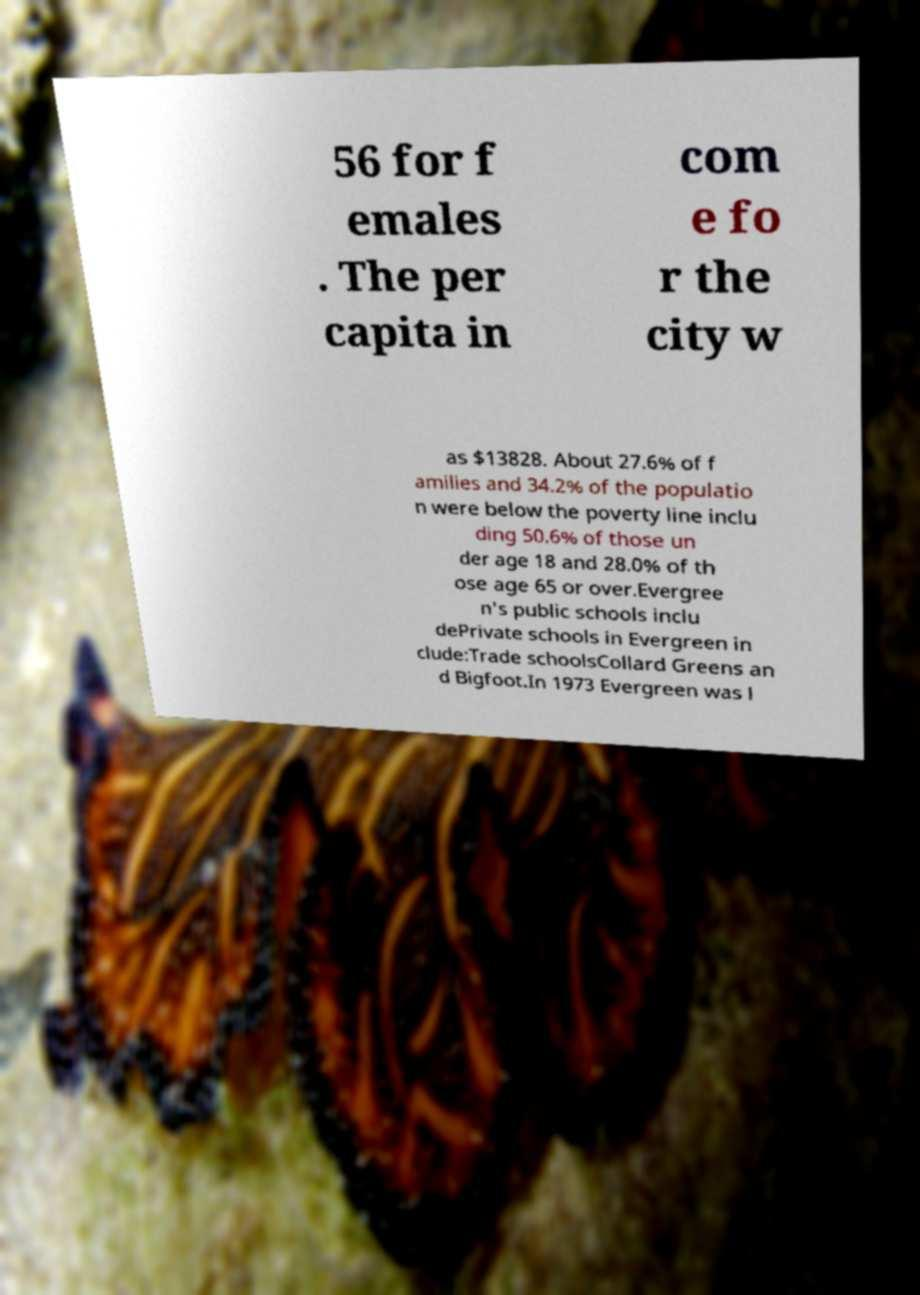Can you accurately transcribe the text from the provided image for me? 56 for f emales . The per capita in com e fo r the city w as $13828. About 27.6% of f amilies and 34.2% of the populatio n were below the poverty line inclu ding 50.6% of those un der age 18 and 28.0% of th ose age 65 or over.Evergree n's public schools inclu dePrivate schools in Evergreen in clude:Trade schoolsCollard Greens an d Bigfoot.In 1973 Evergreen was l 